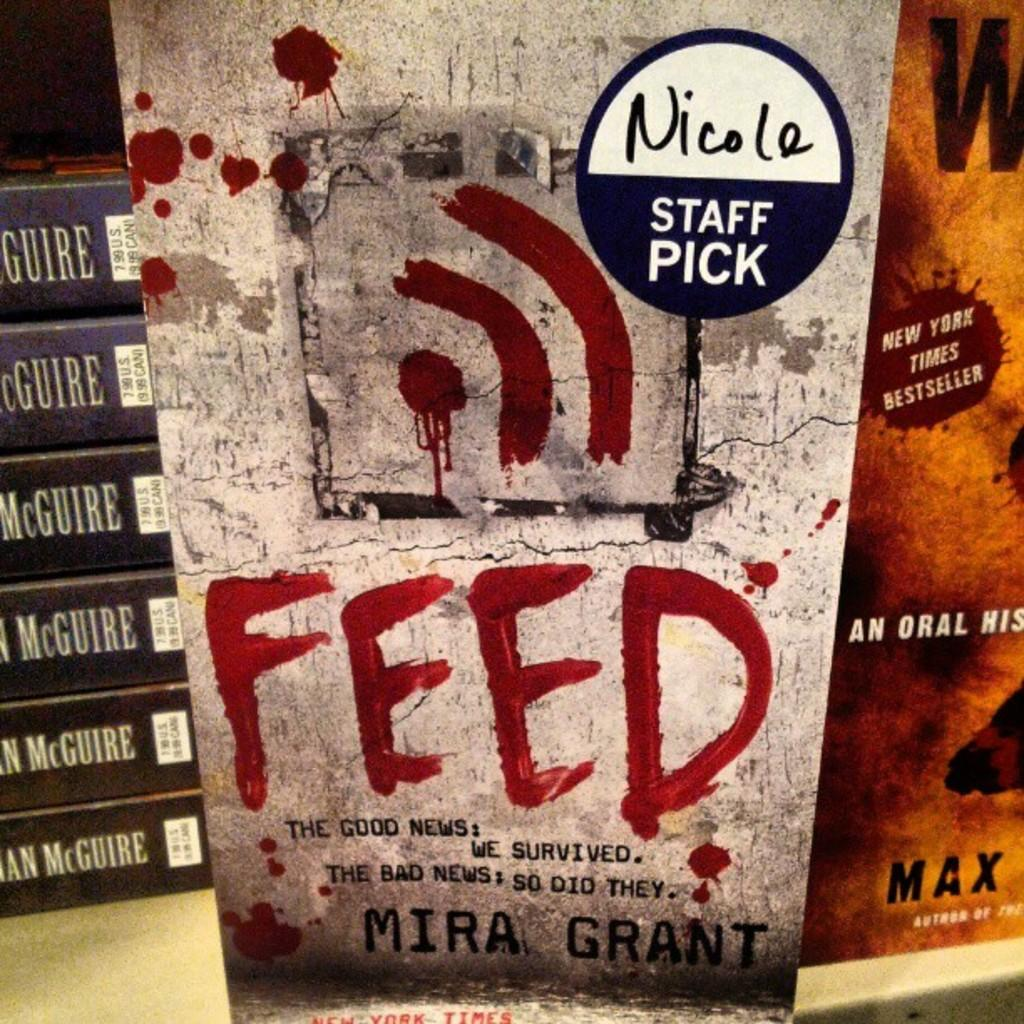What is the main subject in the center of the image? There is a book for staff in the center of the image. How many books are on the surface to the left of the staff book? There are six books on the surface to the left. What is the color of the book on the right side of the image? There is an orange color book on the right. How many ducks are swimming in the book for staff? There are no ducks present in the image, as it features books and not animals. What shape is the book for staff? The book for staff is rectangular in shape, as it is a typical book. 